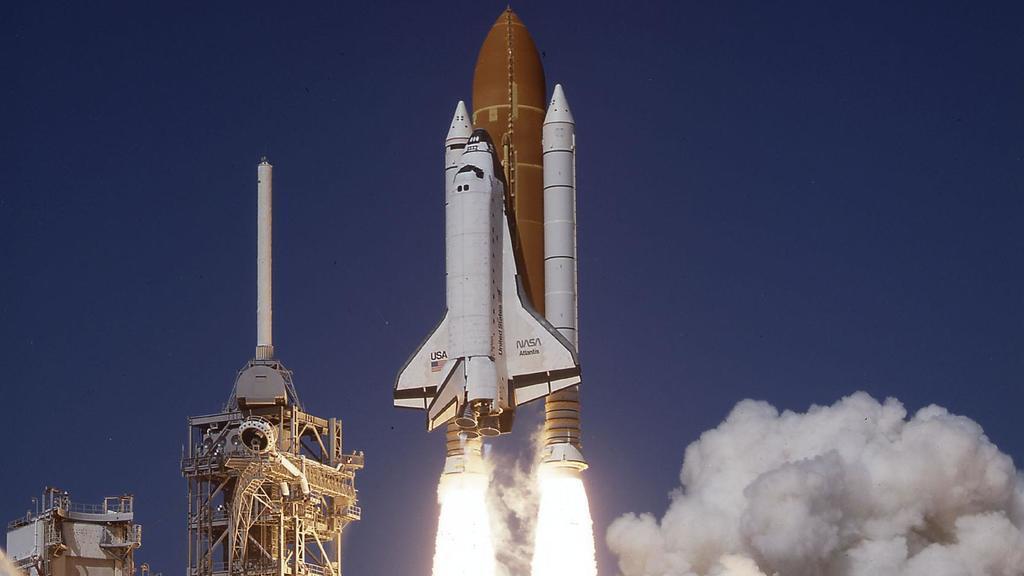Describe this image in one or two sentences. In this image, in the middle, we can see a rocket. On the right side, we can see a smoke. On the left side, we can see some electronic equipment and a rocket. In the background, we can see blue color, at the bottom, we can see a fire. 